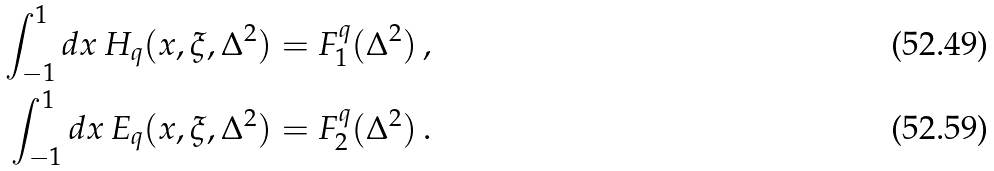Convert formula to latex. <formula><loc_0><loc_0><loc_500><loc_500>\int _ { - 1 } ^ { 1 } d x \, H _ { q } ( x , \xi , \Delta ^ { 2 } ) & = F ^ { q } _ { 1 } ( \Delta ^ { 2 } ) \, , \\ \int _ { - 1 } ^ { 1 } d x \, E _ { q } ( x , \xi , \Delta ^ { 2 } ) & = F ^ { q } _ { 2 } ( \Delta ^ { 2 } ) \, .</formula> 